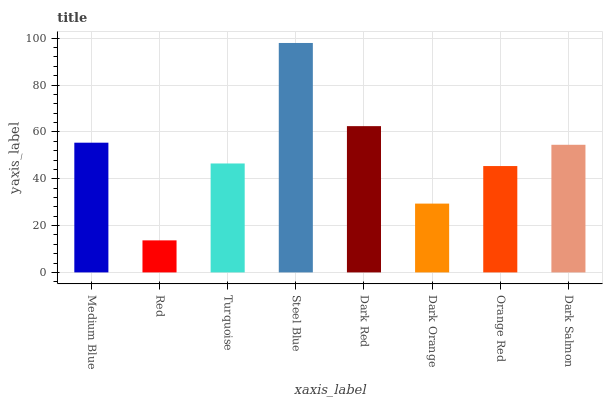Is Turquoise the minimum?
Answer yes or no. No. Is Turquoise the maximum?
Answer yes or no. No. Is Turquoise greater than Red?
Answer yes or no. Yes. Is Red less than Turquoise?
Answer yes or no. Yes. Is Red greater than Turquoise?
Answer yes or no. No. Is Turquoise less than Red?
Answer yes or no. No. Is Dark Salmon the high median?
Answer yes or no. Yes. Is Turquoise the low median?
Answer yes or no. Yes. Is Orange Red the high median?
Answer yes or no. No. Is Dark Red the low median?
Answer yes or no. No. 